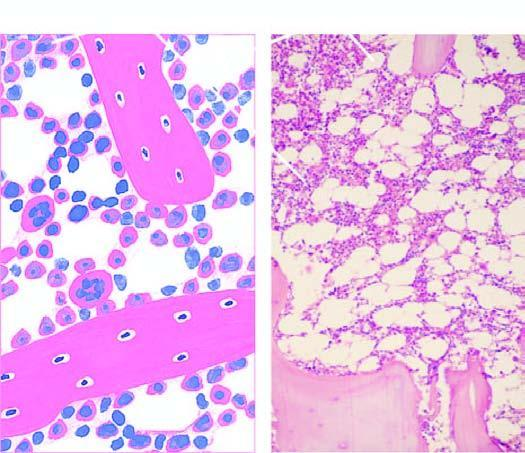what is fatty marrow?
Answer the question using a single word or phrase. 50% of the soft tissue of the bone 